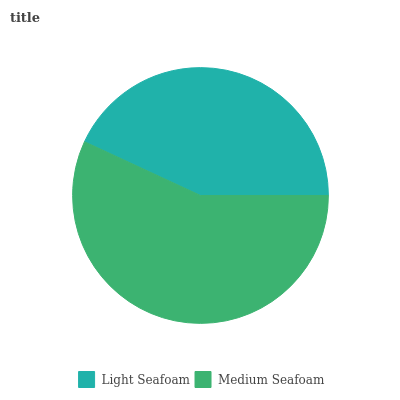Is Light Seafoam the minimum?
Answer yes or no. Yes. Is Medium Seafoam the maximum?
Answer yes or no. Yes. Is Medium Seafoam the minimum?
Answer yes or no. No. Is Medium Seafoam greater than Light Seafoam?
Answer yes or no. Yes. Is Light Seafoam less than Medium Seafoam?
Answer yes or no. Yes. Is Light Seafoam greater than Medium Seafoam?
Answer yes or no. No. Is Medium Seafoam less than Light Seafoam?
Answer yes or no. No. Is Medium Seafoam the high median?
Answer yes or no. Yes. Is Light Seafoam the low median?
Answer yes or no. Yes. Is Light Seafoam the high median?
Answer yes or no. No. Is Medium Seafoam the low median?
Answer yes or no. No. 